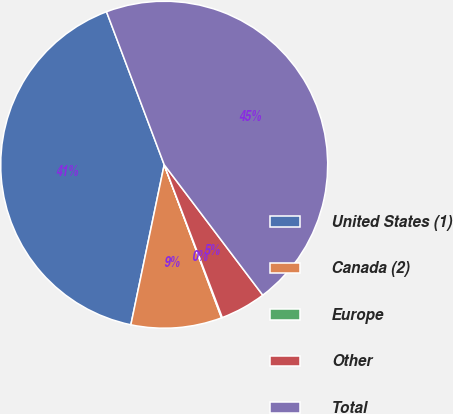Convert chart. <chart><loc_0><loc_0><loc_500><loc_500><pie_chart><fcel>United States (1)<fcel>Canada (2)<fcel>Europe<fcel>Other<fcel>Total<nl><fcel>40.99%<fcel>8.97%<fcel>0.08%<fcel>4.52%<fcel>45.44%<nl></chart> 